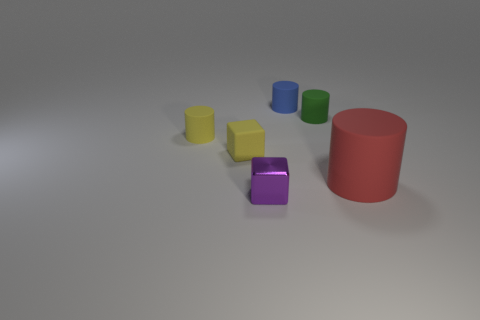Add 2 big matte objects. How many objects exist? 8 Subtract all cylinders. How many objects are left? 2 Subtract 0 blue cubes. How many objects are left? 6 Subtract all tiny red metallic objects. Subtract all large rubber cylinders. How many objects are left? 5 Add 4 tiny yellow rubber blocks. How many tiny yellow rubber blocks are left? 5 Add 2 yellow blocks. How many yellow blocks exist? 3 